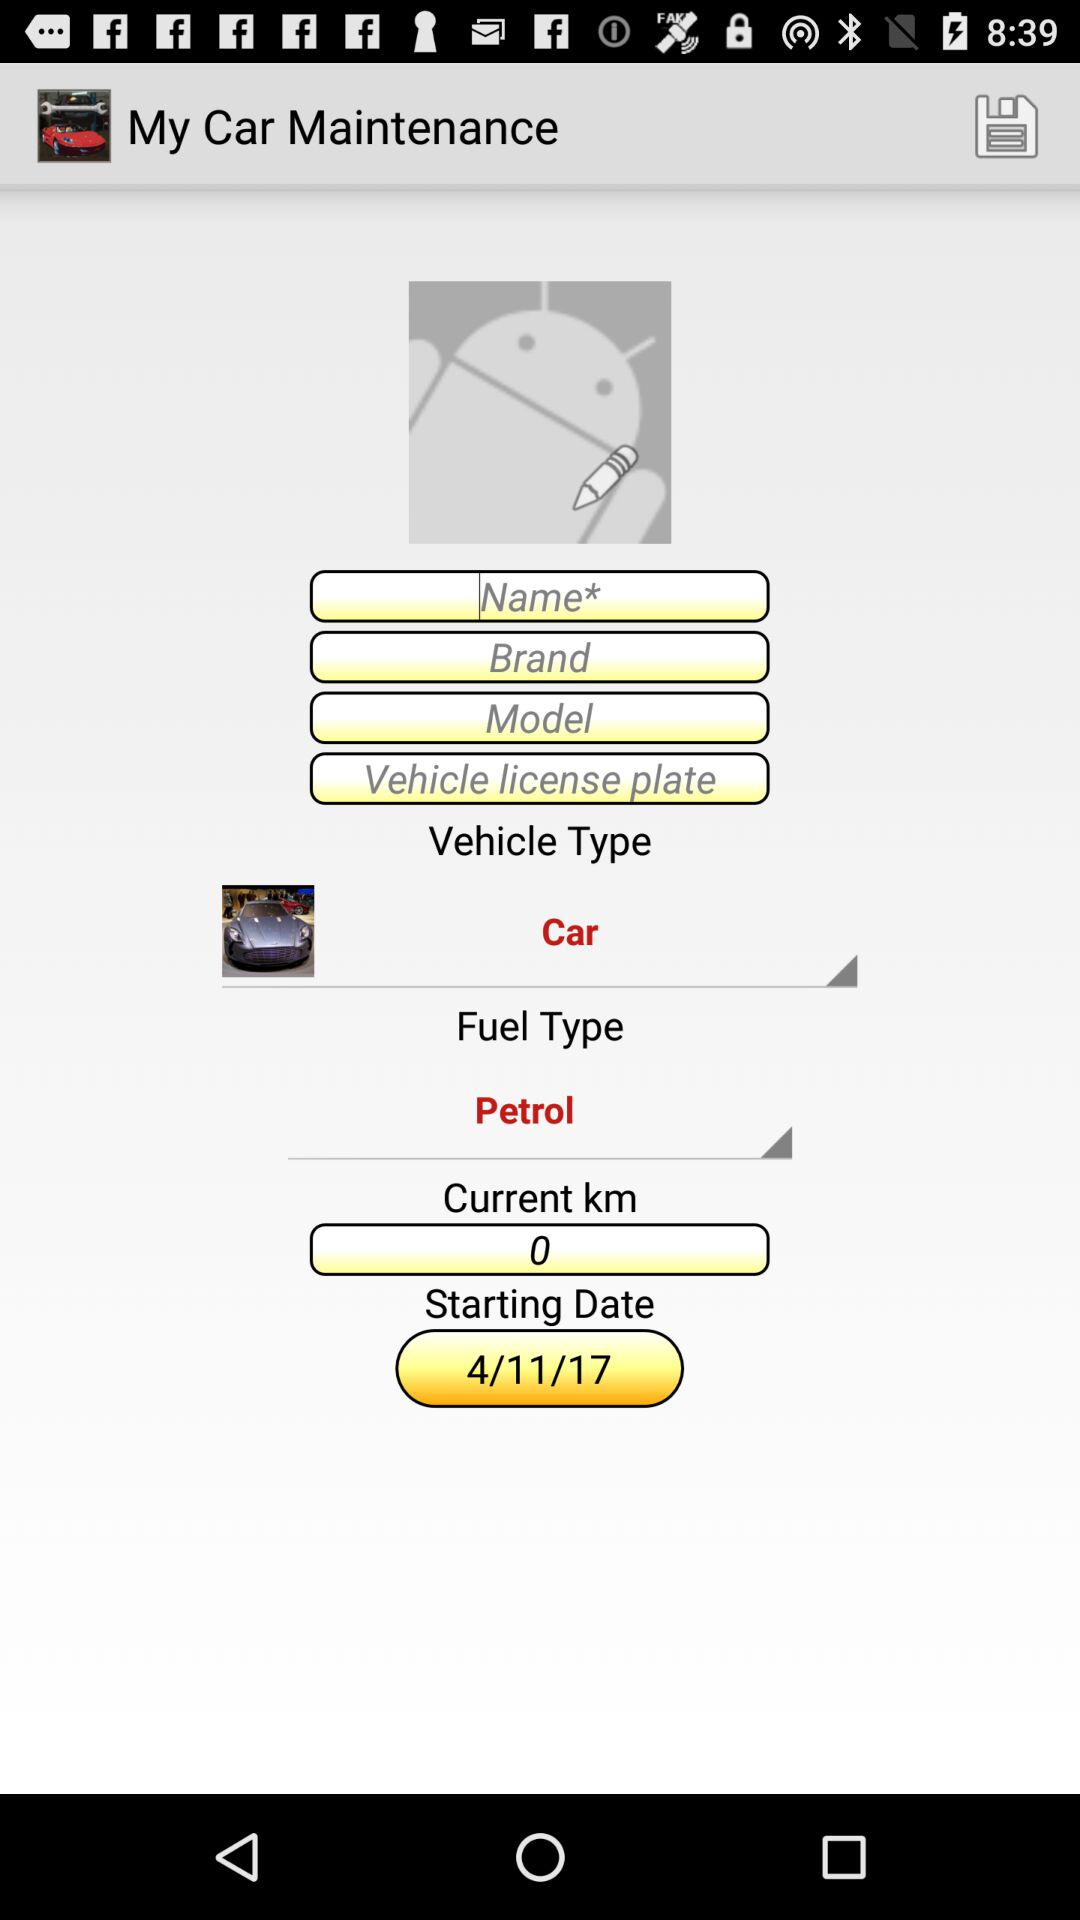What is the fuel type? The fuel type is "Petrol". 